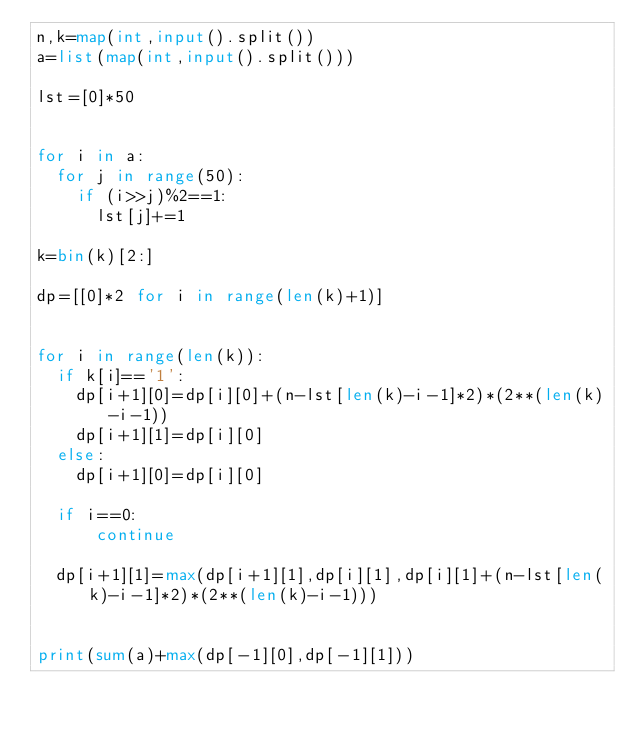<code> <loc_0><loc_0><loc_500><loc_500><_Python_>n,k=map(int,input().split())
a=list(map(int,input().split()))

lst=[0]*50


for i in a:
  for j in range(50):
    if (i>>j)%2==1:
      lst[j]+=1

k=bin(k)[2:]

dp=[[0]*2 for i in range(len(k)+1)]


for i in range(len(k)):
  if k[i]=='1':
    dp[i+1][0]=dp[i][0]+(n-lst[len(k)-i-1]*2)*(2**(len(k)-i-1))
    dp[i+1][1]=dp[i][0]
  else:
    dp[i+1][0]=dp[i][0]

  if i==0:
      continue
  
  dp[i+1][1]=max(dp[i+1][1],dp[i][1],dp[i][1]+(n-lst[len(k)-i-1]*2)*(2**(len(k)-i-1)))


print(sum(a)+max(dp[-1][0],dp[-1][1]))</code> 